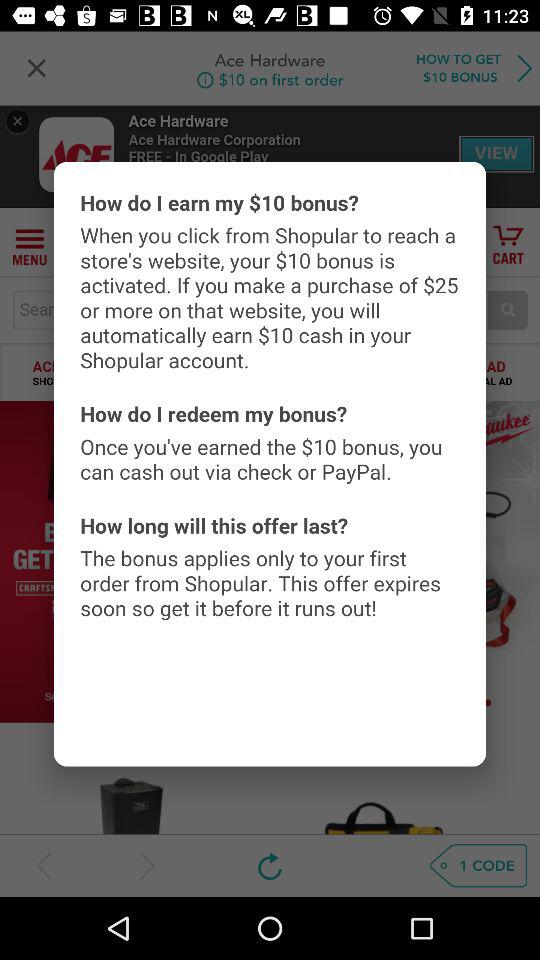What is the currency for the bonus? The currency is dollars. 